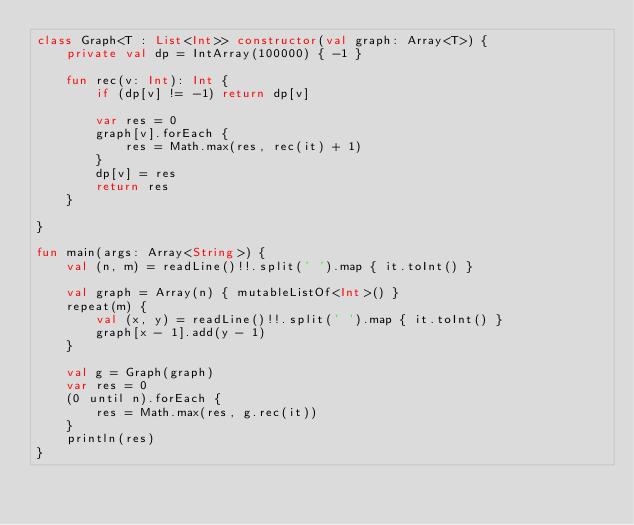<code> <loc_0><loc_0><loc_500><loc_500><_Kotlin_>class Graph<T : List<Int>> constructor(val graph: Array<T>) {
    private val dp = IntArray(100000) { -1 }

    fun rec(v: Int): Int {
        if (dp[v] != -1) return dp[v]

        var res = 0
        graph[v].forEach {
            res = Math.max(res, rec(it) + 1)
        }
        dp[v] = res
        return res
    }

}

fun main(args: Array<String>) {
    val (n, m) = readLine()!!.split(' ').map { it.toInt() }

    val graph = Array(n) { mutableListOf<Int>() }
    repeat(m) {
        val (x, y) = readLine()!!.split(' ').map { it.toInt() }
        graph[x - 1].add(y - 1)
    }

    val g = Graph(graph)
    var res = 0
    (0 until n).forEach {
        res = Math.max(res, g.rec(it))
    }
    println(res)
}
</code> 